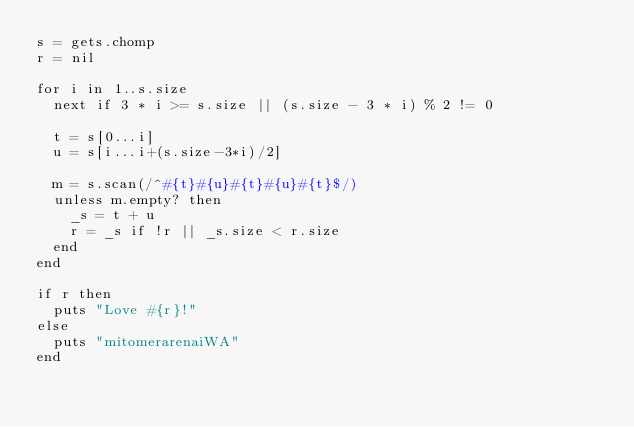Convert code to text. <code><loc_0><loc_0><loc_500><loc_500><_Ruby_>s = gets.chomp
r = nil

for i in 1..s.size
  next if 3 * i >= s.size || (s.size - 3 * i) % 2 != 0
  
  t = s[0...i]
  u = s[i...i+(s.size-3*i)/2]
  
  m = s.scan(/^#{t}#{u}#{t}#{u}#{t}$/)
  unless m.empty? then
    _s = t + u
    r = _s if !r || _s.size < r.size 
  end
end

if r then
  puts "Love #{r}!"
else
  puts "mitomerarenaiWA"
end</code> 